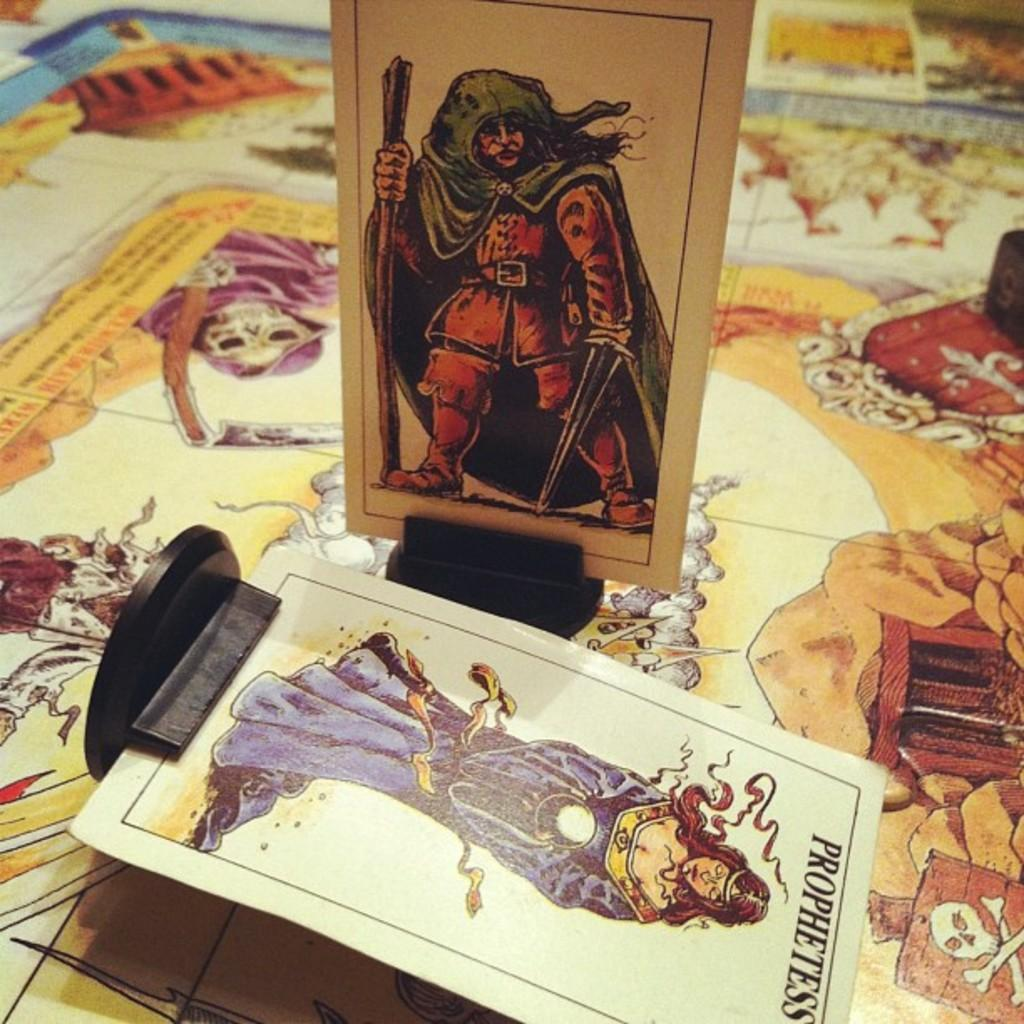What type of objects are present on the poster in the image? There are image cards with stands in the image. What is the purpose of the stands on the image cards? The stands are likely used to prop up the image cards on the poster. What can be seen on the image cards? There are images on the image cards. What else is present on the poster besides the image cards? There is text on the poster. Can you tell me how many squirrels are hiding in the cellar in the image? There are no squirrels or cellars present in the image. What is the income of the person in the image? There is no person present in the image. 